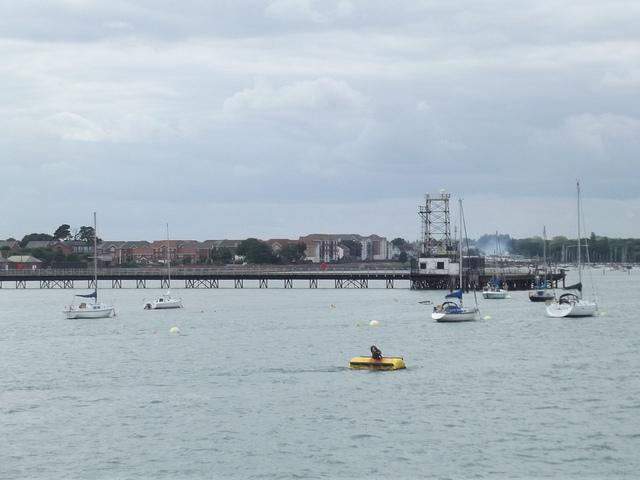What do many of the boats shown here normally use but lack here? Please explain your reasoning. sails. There are many sailboats. 